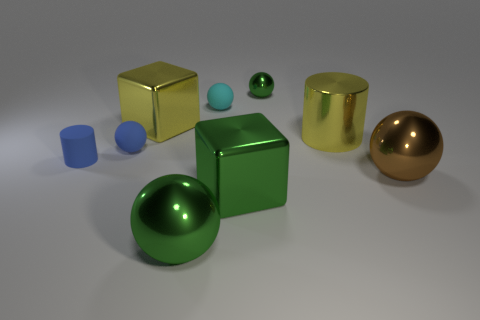Add 1 matte cylinders. How many objects exist? 10 Subtract all green spheres. How many spheres are left? 3 Subtract all red cubes. How many green balls are left? 2 Subtract 4 spheres. How many spheres are left? 1 Subtract all spheres. How many objects are left? 4 Subtract all yellow blocks. How many blocks are left? 1 Subtract all shiny cubes. Subtract all cyan balls. How many objects are left? 6 Add 4 large green balls. How many large green balls are left? 5 Add 8 big cylinders. How many big cylinders exist? 9 Subtract 0 purple cylinders. How many objects are left? 9 